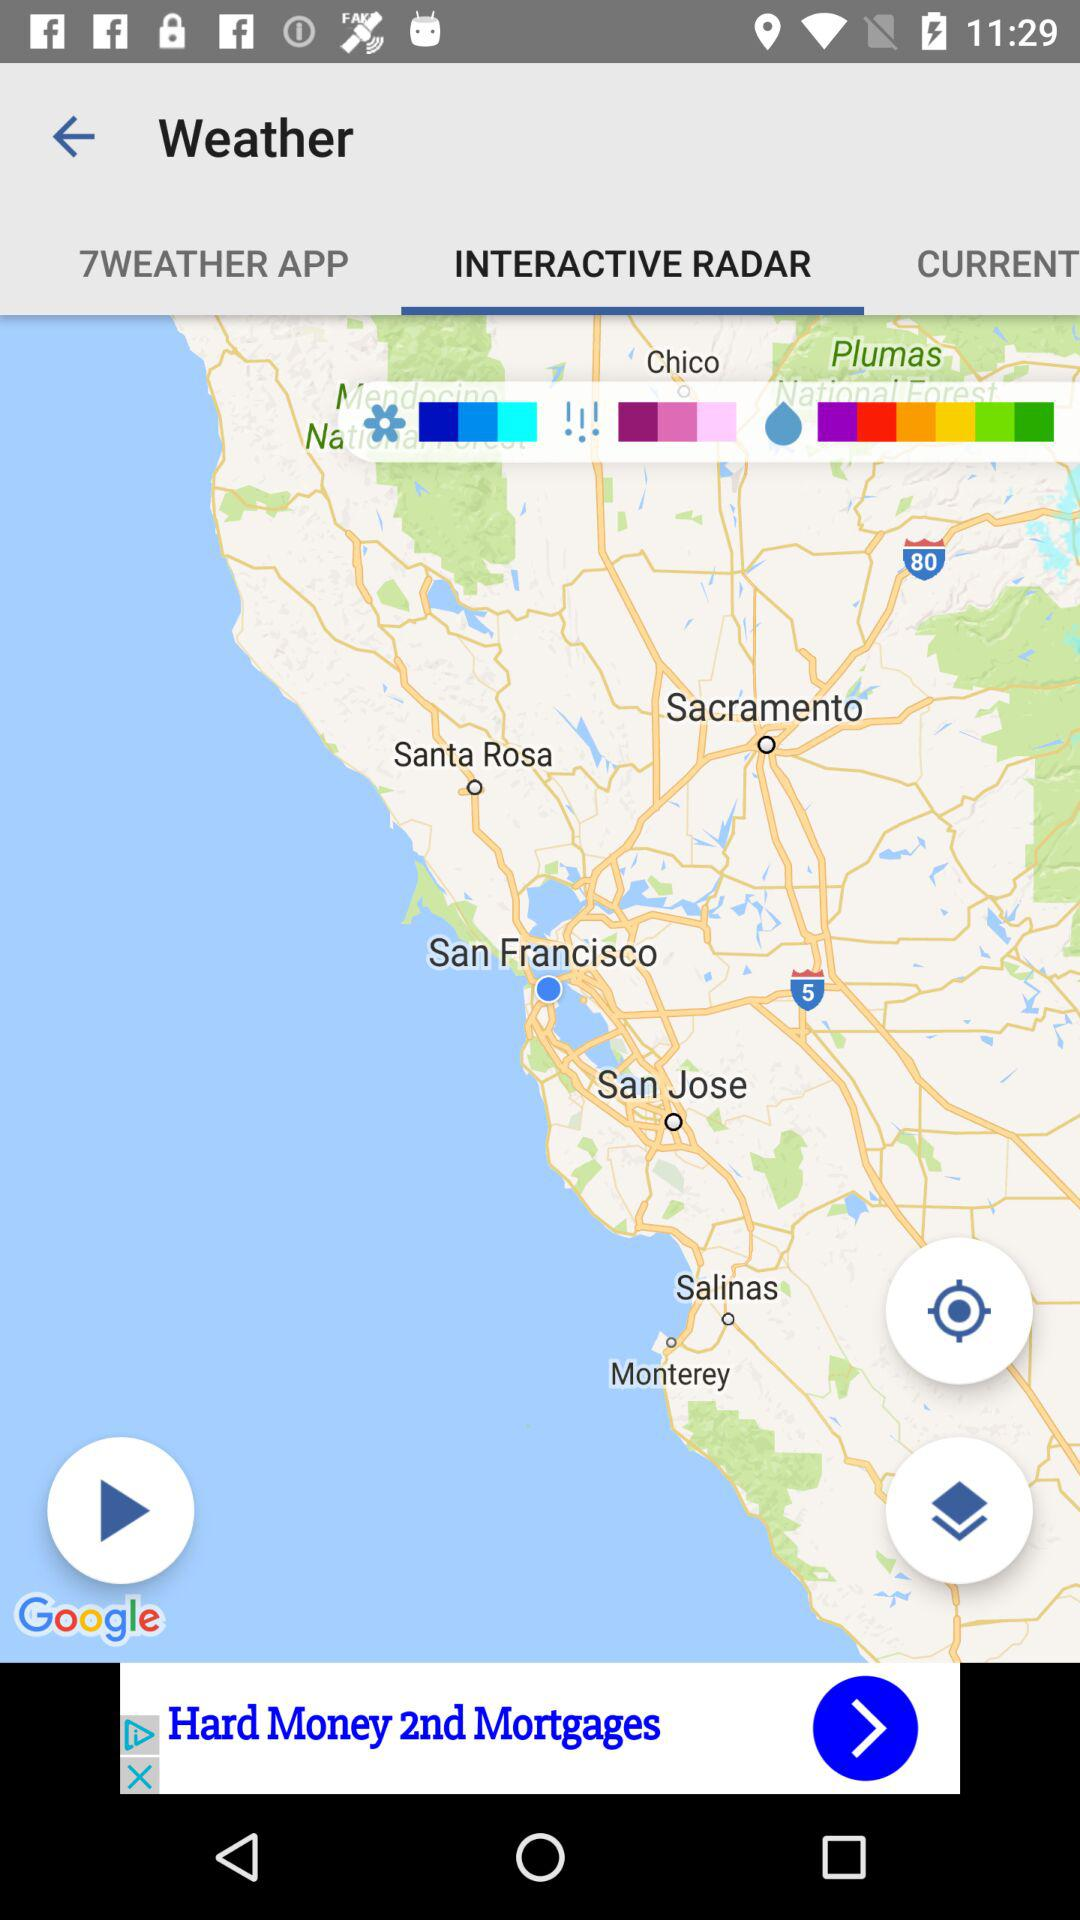What is the selected location?
When the provided information is insufficient, respond with <no answer>. <no answer> 